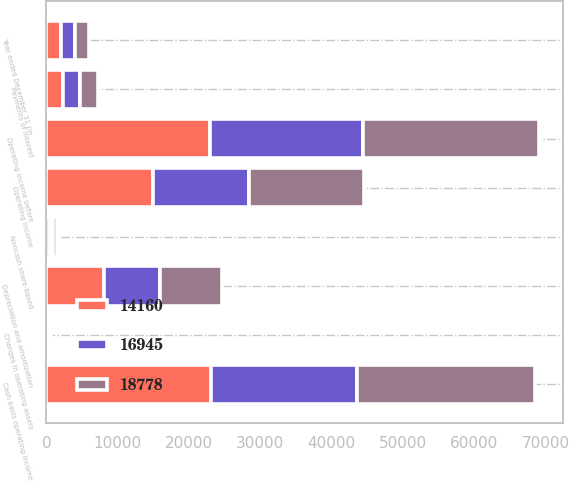Convert chart. <chart><loc_0><loc_0><loc_500><loc_500><stacked_bar_chart><ecel><fcel>Year ended December 31 (in<fcel>Operating income<fcel>Depreciation and amortization<fcel>Operating income before<fcel>Noncash share-based<fcel>Changes in operating assets<fcel>Cash basis operating income<fcel>Payments of interest<nl><fcel>18778<fcel>2015<fcel>15998<fcel>8680<fcel>24678<fcel>567<fcel>267<fcel>24978<fcel>2443<nl><fcel>14160<fcel>2014<fcel>14904<fcel>8019<fcel>22923<fcel>513<fcel>357<fcel>23079<fcel>2389<nl><fcel>16945<fcel>2013<fcel>13563<fcel>7871<fcel>21434<fcel>419<fcel>93<fcel>20504<fcel>2355<nl></chart> 